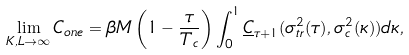<formula> <loc_0><loc_0><loc_500><loc_500>\lim _ { K , L \rightarrow \infty } C _ { o n e } = \beta M \left ( 1 - \frac { \tau } { T _ { c } } \right ) \int _ { 0 } ^ { 1 } \underline { C } _ { \tau + 1 } ( \sigma _ { t r } ^ { 2 } ( \tau ) , \sigma _ { c } ^ { 2 } ( \kappa ) ) d \kappa ,</formula> 